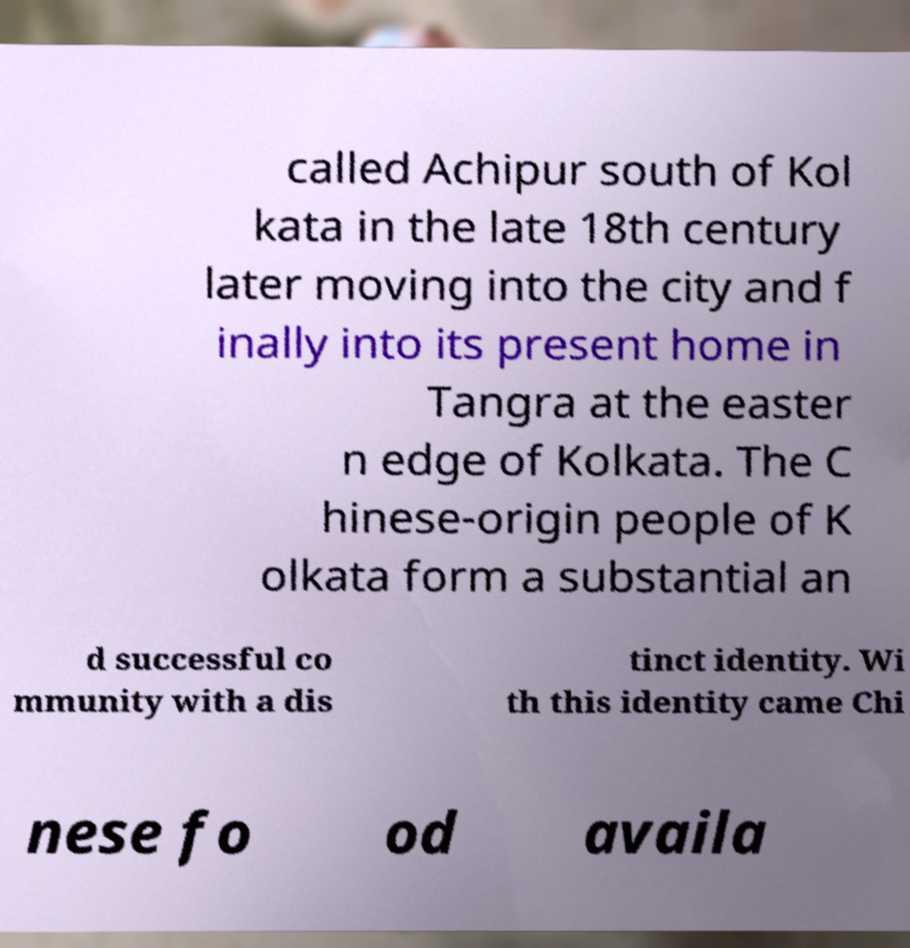Could you assist in decoding the text presented in this image and type it out clearly? called Achipur south of Kol kata in the late 18th century later moving into the city and f inally into its present home in Tangra at the easter n edge of Kolkata. The C hinese-origin people of K olkata form a substantial an d successful co mmunity with a dis tinct identity. Wi th this identity came Chi nese fo od availa 